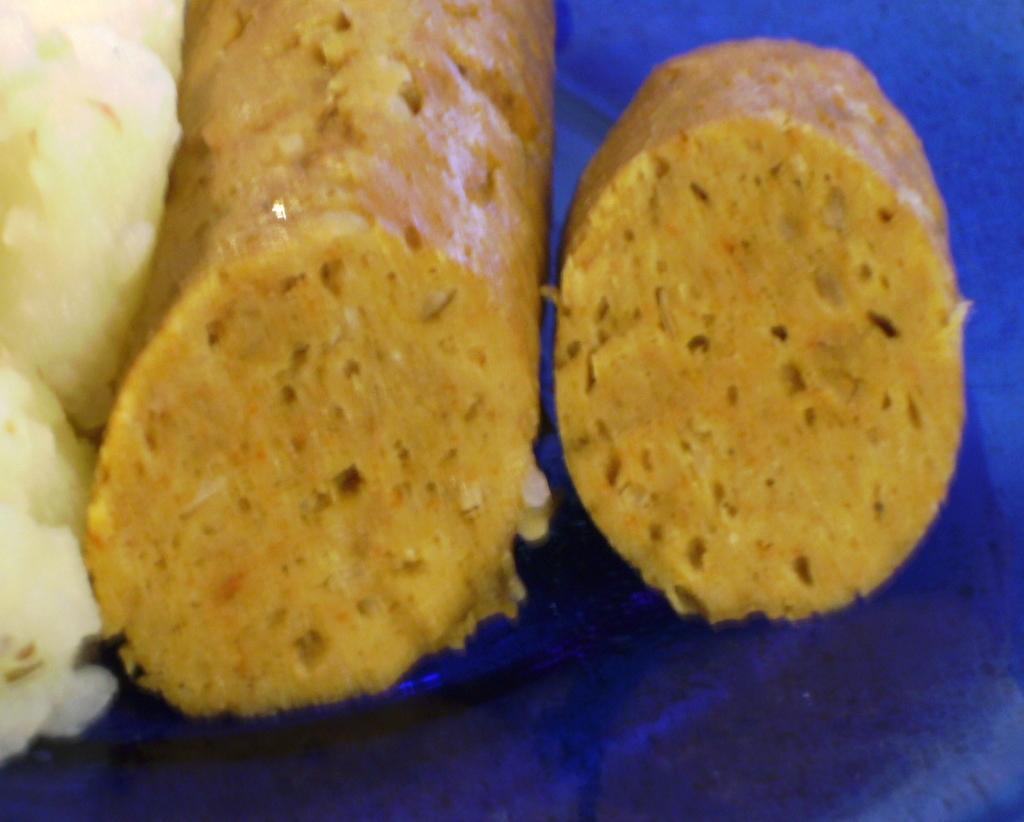How would you summarize this image in a sentence or two? This is a zoomed in picture. In the center we can see there are some food items placed on the top of the surface of a blue color object. 